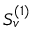Convert formula to latex. <formula><loc_0><loc_0><loc_500><loc_500>S _ { v } ^ { ( 1 ) }</formula> 